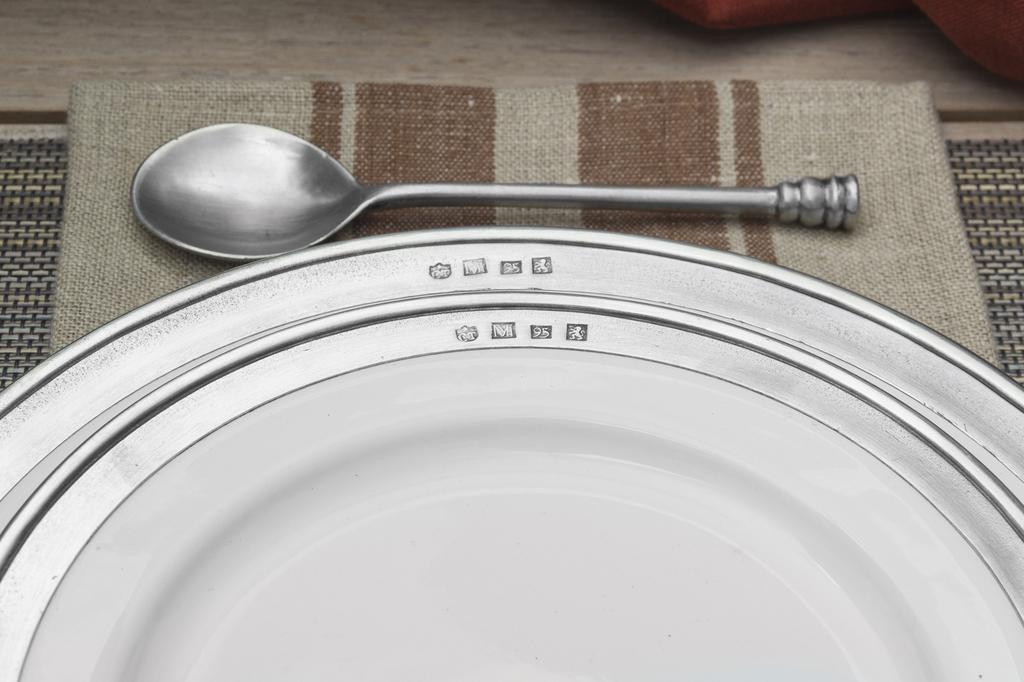Can you describe this image briefly? There is a white color plate and steel spoon on a cloth. Which is on the other cloth. 